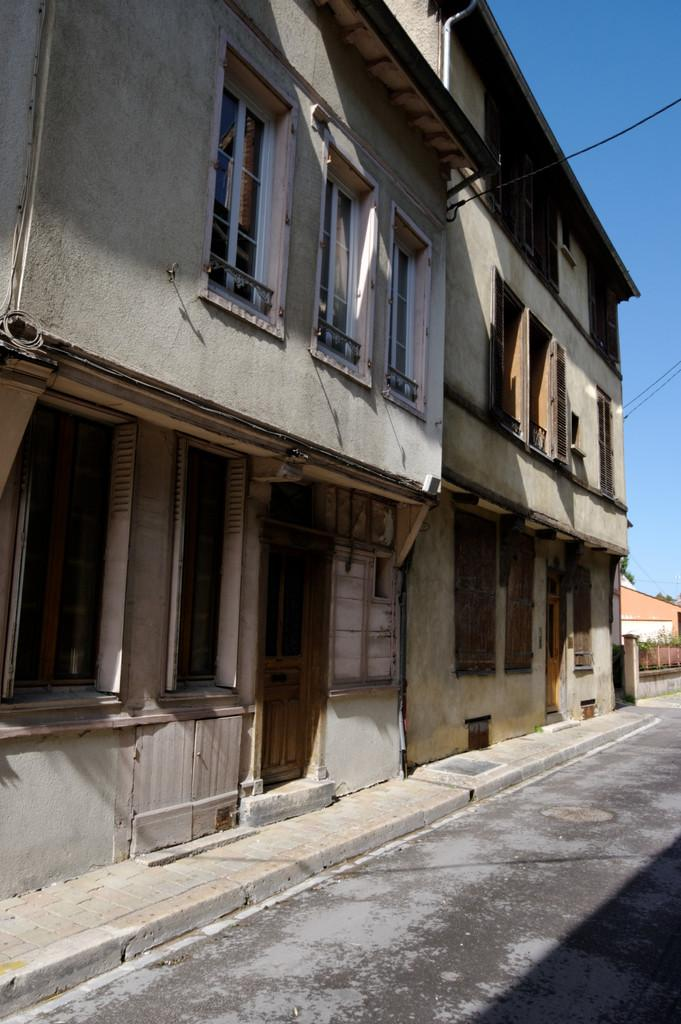What type of structure is in the image? There is a building in the image. What features can be seen on the building? The building has windows and a door. What can be seen in the background of the image? The sky is visible in the background of the image. Can you tell me how many chess pieces are on the roof of the building in the image? There are no chess pieces visible on the roof of the building in the image. What type of hydrant is located near the building in the image? There is no hydrant present near the building in the image. 